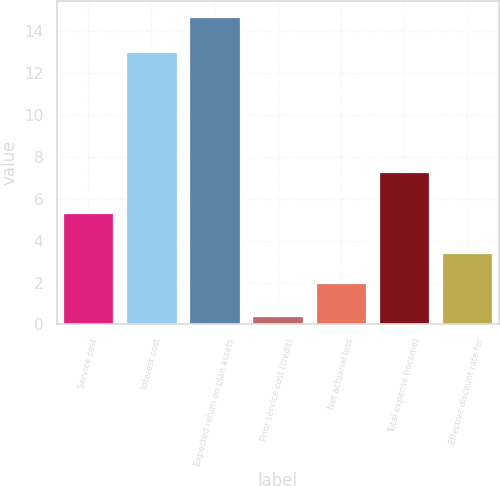Convert chart to OTSL. <chart><loc_0><loc_0><loc_500><loc_500><bar_chart><fcel>Service cost<fcel>Interest cost<fcel>Expected return on plan assets<fcel>Prior service cost (credit)<fcel>Net actuarial loss<fcel>Total expense (income)<fcel>Effective discount rate for<nl><fcel>5.3<fcel>13<fcel>14.7<fcel>0.4<fcel>2<fcel>7.3<fcel>3.43<nl></chart> 